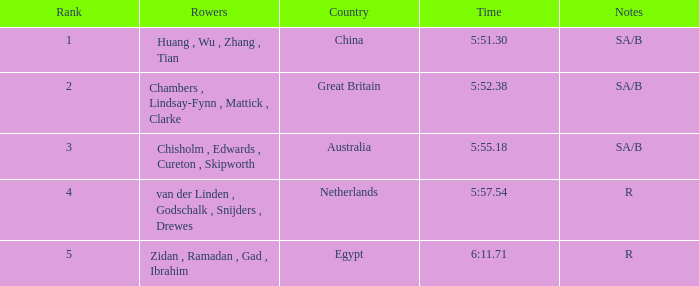Which nation possesses sa/b as the notations, and a duration of 5:5 China. 